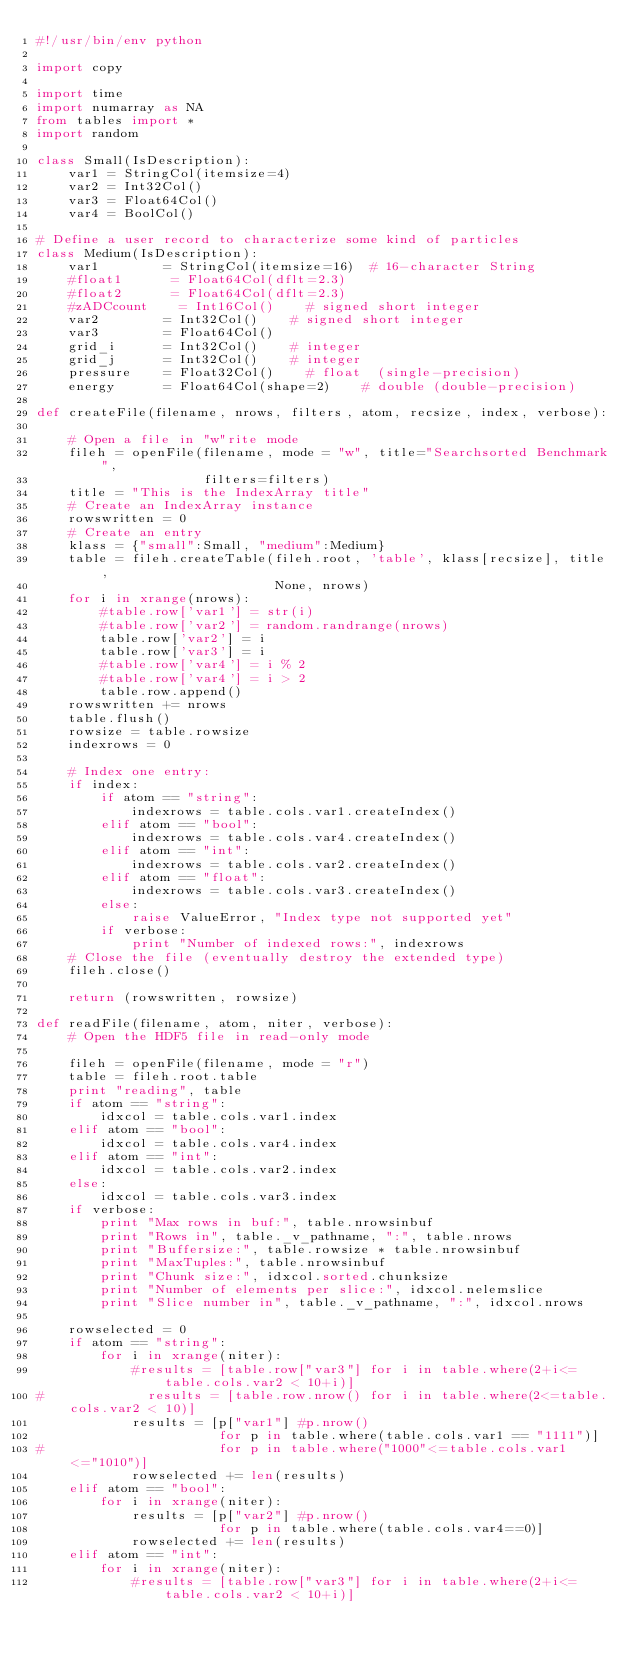Convert code to text. <code><loc_0><loc_0><loc_500><loc_500><_Python_>#!/usr/bin/env python

import copy

import time
import numarray as NA
from tables import *
import random

class Small(IsDescription):
    var1 = StringCol(itemsize=4)
    var2 = Int32Col()
    var3 = Float64Col()
    var4 = BoolCol()

# Define a user record to characterize some kind of particles
class Medium(IsDescription):
    var1        = StringCol(itemsize=16)  # 16-character String
    #float1      = Float64Col(dflt=2.3)
    #float2      = Float64Col(dflt=2.3)
    #zADCcount    = Int16Col()    # signed short integer
    var2        = Int32Col()    # signed short integer
    var3        = Float64Col()
    grid_i      = Int32Col()    # integer
    grid_j      = Int32Col()    # integer
    pressure    = Float32Col()    # float  (single-precision)
    energy      = Float64Col(shape=2)    # double (double-precision)

def createFile(filename, nrows, filters, atom, recsize, index, verbose):

    # Open a file in "w"rite mode
    fileh = openFile(filename, mode = "w", title="Searchsorted Benchmark",
                     filters=filters)
    title = "This is the IndexArray title"
    # Create an IndexArray instance
    rowswritten = 0
    # Create an entry
    klass = {"small":Small, "medium":Medium}
    table = fileh.createTable(fileh.root, 'table', klass[recsize], title,
                              None, nrows)
    for i in xrange(nrows):
        #table.row['var1'] = str(i)
        #table.row['var2'] = random.randrange(nrows)
        table.row['var2'] = i
        table.row['var3'] = i
        #table.row['var4'] = i % 2
        #table.row['var4'] = i > 2
        table.row.append()
    rowswritten += nrows
    table.flush()
    rowsize = table.rowsize
    indexrows = 0

    # Index one entry:
    if index:
        if atom == "string":
            indexrows = table.cols.var1.createIndex()
        elif atom == "bool":
            indexrows = table.cols.var4.createIndex()
        elif atom == "int":
            indexrows = table.cols.var2.createIndex()
        elif atom == "float":
            indexrows = table.cols.var3.createIndex()
        else:
            raise ValueError, "Index type not supported yet"
        if verbose:
            print "Number of indexed rows:", indexrows
    # Close the file (eventually destroy the extended type)
    fileh.close()

    return (rowswritten, rowsize)

def readFile(filename, atom, niter, verbose):
    # Open the HDF5 file in read-only mode

    fileh = openFile(filename, mode = "r")
    table = fileh.root.table
    print "reading", table
    if atom == "string":
        idxcol = table.cols.var1.index
    elif atom == "bool":
        idxcol = table.cols.var4.index
    elif atom == "int":
        idxcol = table.cols.var2.index
    else:
        idxcol = table.cols.var3.index
    if verbose:
        print "Max rows in buf:", table.nrowsinbuf
        print "Rows in", table._v_pathname, ":", table.nrows
        print "Buffersize:", table.rowsize * table.nrowsinbuf
        print "MaxTuples:", table.nrowsinbuf
        print "Chunk size:", idxcol.sorted.chunksize
        print "Number of elements per slice:", idxcol.nelemslice
        print "Slice number in", table._v_pathname, ":", idxcol.nrows

    rowselected = 0
    if atom == "string":
        for i in xrange(niter):
            #results = [table.row["var3"] for i in table.where(2+i<=table.cols.var2 < 10+i)]
#             results = [table.row.nrow() for i in table.where(2<=table.cols.var2 < 10)]
            results = [p["var1"] #p.nrow()
                       for p in table.where(table.cols.var1 == "1111")]
#                      for p in table.where("1000"<=table.cols.var1<="1010")]
            rowselected += len(results)
    elif atom == "bool":
        for i in xrange(niter):
            results = [p["var2"] #p.nrow()
                       for p in table.where(table.cols.var4==0)]
            rowselected += len(results)
    elif atom == "int":
        for i in xrange(niter):
            #results = [table.row["var3"] for i in table.where(2+i<=table.cols.var2 < 10+i)]</code> 